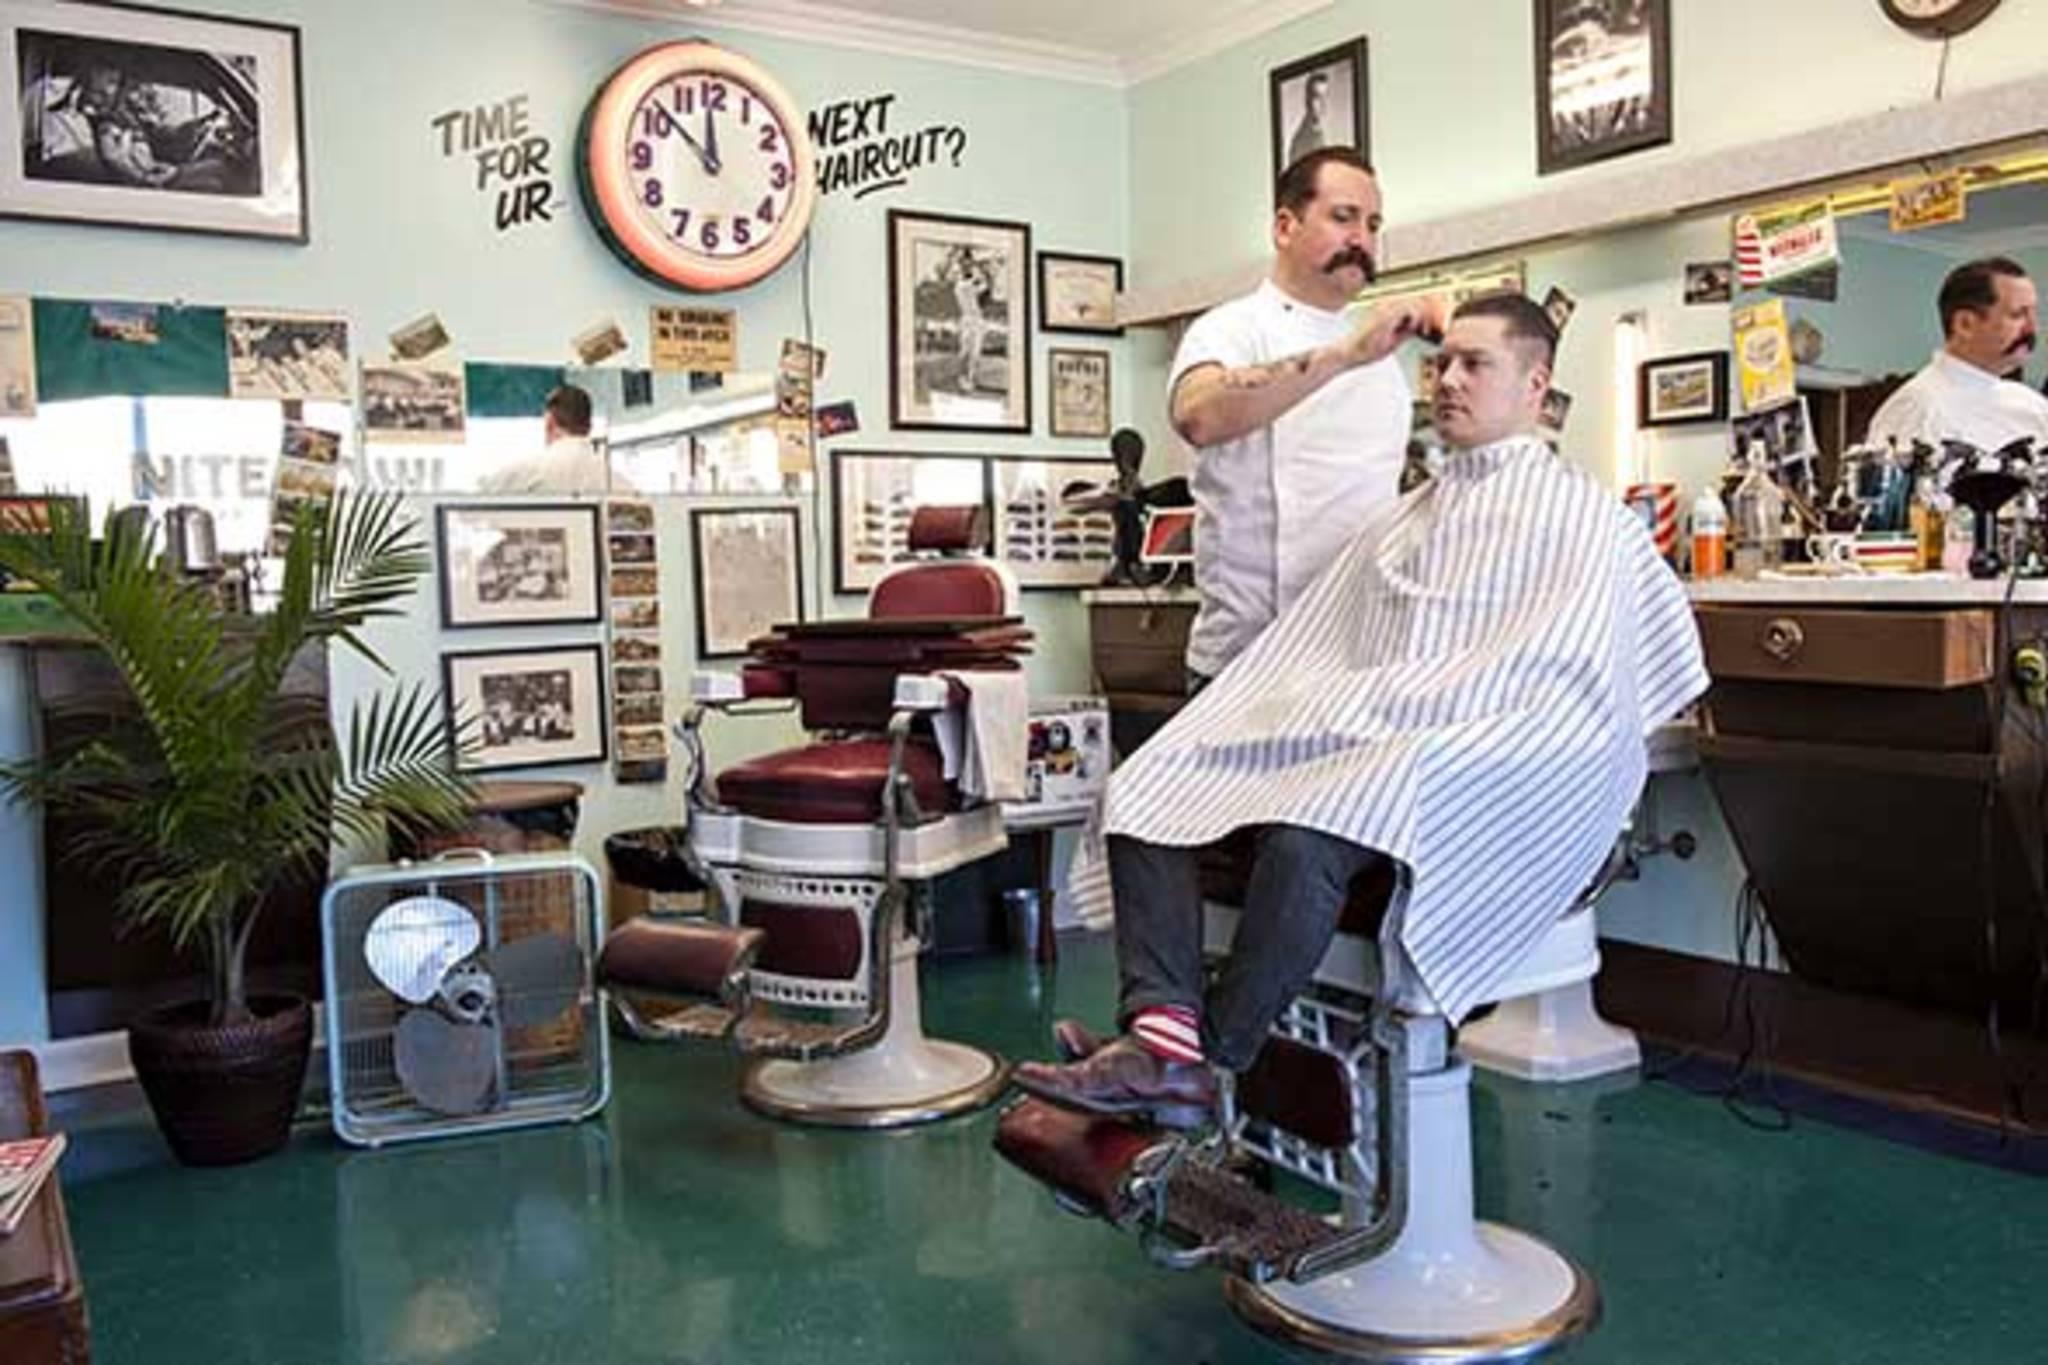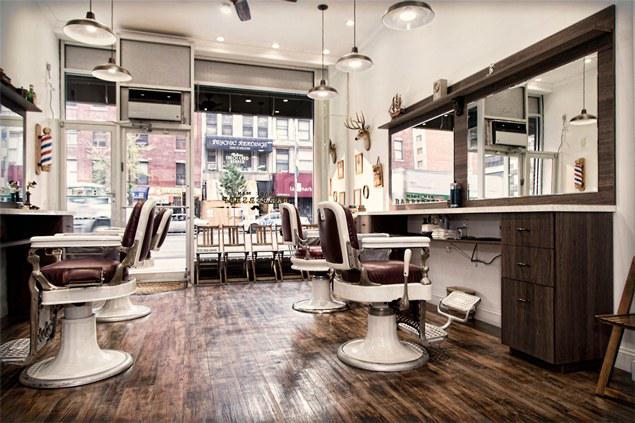The first image is the image on the left, the second image is the image on the right. For the images shown, is this caption "There are at least four people in the image on the right." true? Answer yes or no. No. 